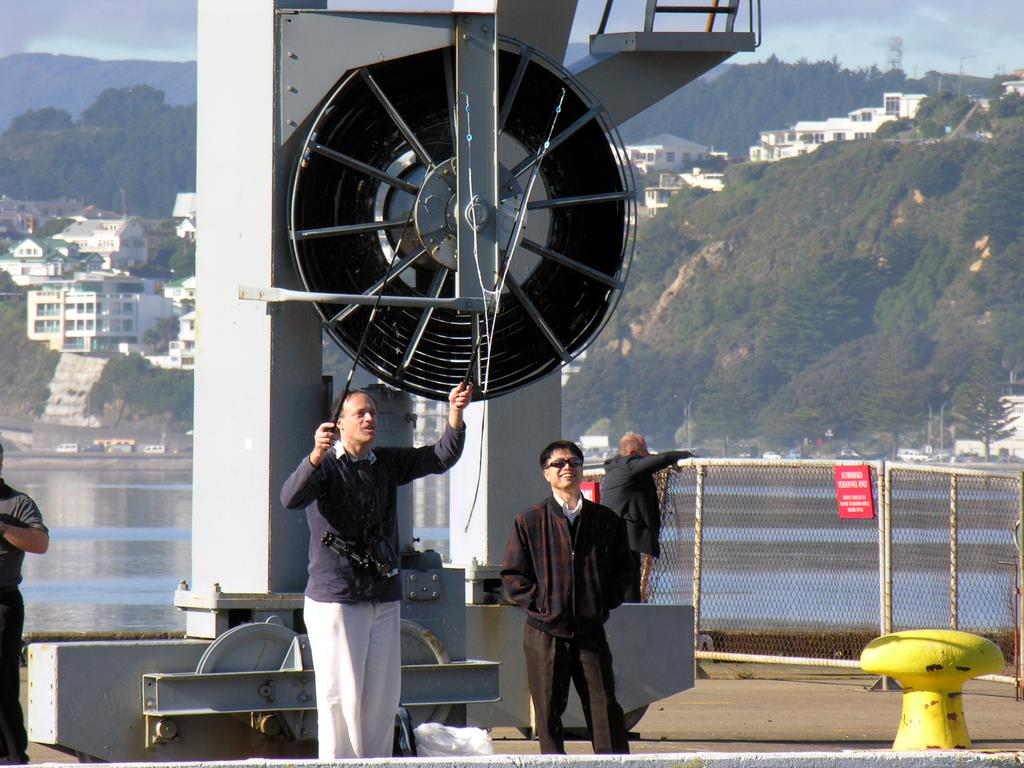How many people are in the image? There is a group of people in the image, but the exact number cannot be determined from the provided facts. What objects can be seen in the image besides the people? Metal rods, a fence, and sign boards are visible in the image. What can be seen in the background of the image? Water, buildings, trees, and hills are visible in the background. Are there any cattle grazing in the park in the image? There is no park present in the image, and therefore no cattle grazing can be observed. 